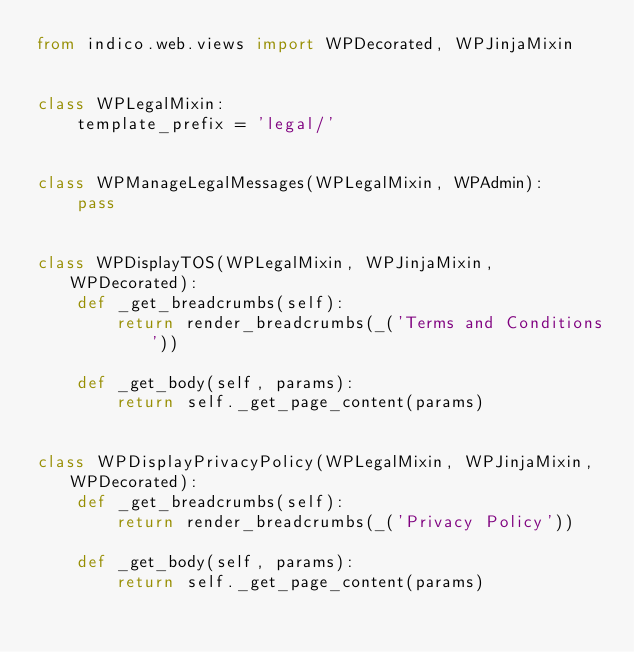Convert code to text. <code><loc_0><loc_0><loc_500><loc_500><_Python_>from indico.web.views import WPDecorated, WPJinjaMixin


class WPLegalMixin:
    template_prefix = 'legal/'


class WPManageLegalMessages(WPLegalMixin, WPAdmin):
    pass


class WPDisplayTOS(WPLegalMixin, WPJinjaMixin, WPDecorated):
    def _get_breadcrumbs(self):
        return render_breadcrumbs(_('Terms and Conditions'))

    def _get_body(self, params):
        return self._get_page_content(params)


class WPDisplayPrivacyPolicy(WPLegalMixin, WPJinjaMixin, WPDecorated):
    def _get_breadcrumbs(self):
        return render_breadcrumbs(_('Privacy Policy'))

    def _get_body(self, params):
        return self._get_page_content(params)
</code> 